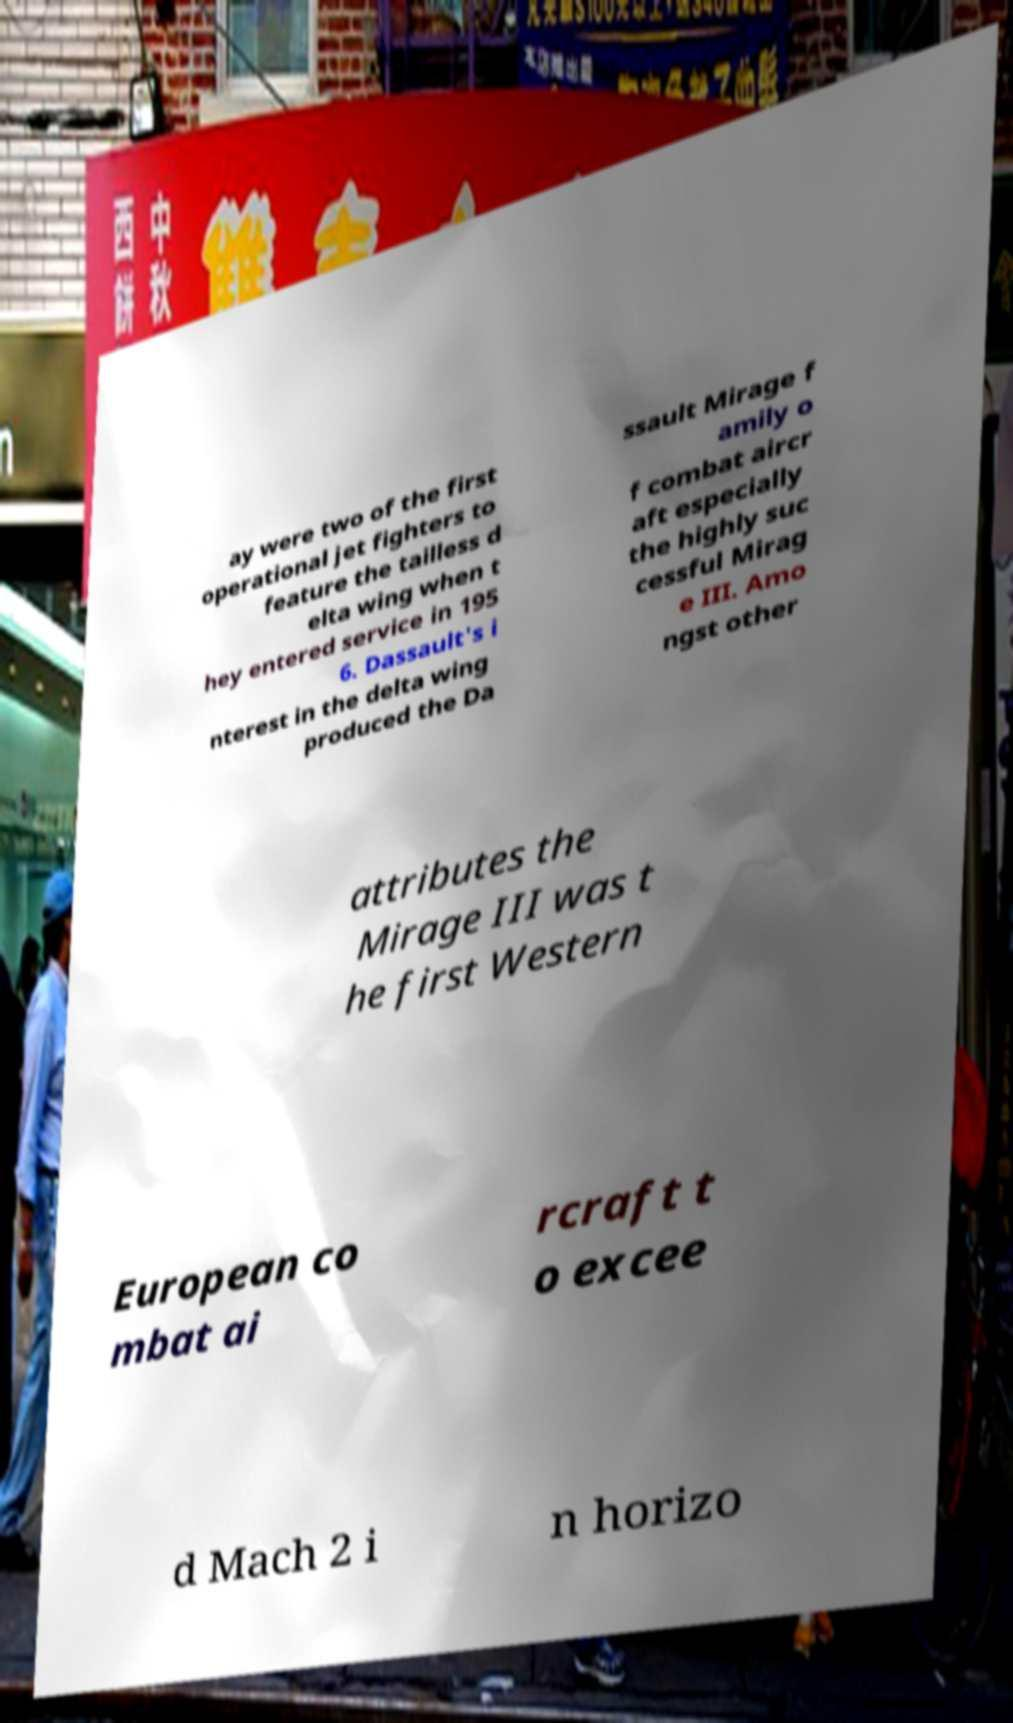Could you extract and type out the text from this image? ay were two of the first operational jet fighters to feature the tailless d elta wing when t hey entered service in 195 6. Dassault's i nterest in the delta wing produced the Da ssault Mirage f amily o f combat aircr aft especially the highly suc cessful Mirag e III. Amo ngst other attributes the Mirage III was t he first Western European co mbat ai rcraft t o excee d Mach 2 i n horizo 